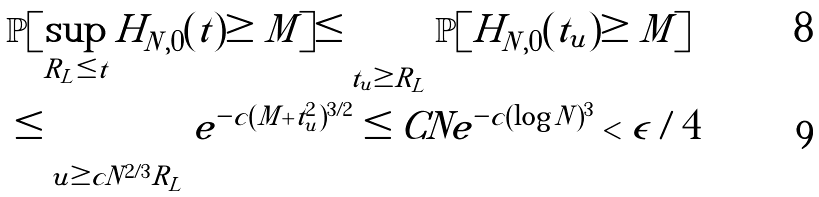Convert formula to latex. <formula><loc_0><loc_0><loc_500><loc_500>& \mathbb { P } [ \sup _ { R _ { L } \leq t } H _ { N , 0 } ( t ) \geq M ] \leq \sum _ { t _ { u } \geq R _ { L } } \mathbb { P } [ H _ { N , 0 } ( t _ { u } ) \geq M ] \\ & \leq \sum _ { u \geq c N ^ { 2 / 3 } R _ { L } } e ^ { - c ( M + t _ { u } ^ { 2 } ) ^ { 3 / 2 } } \leq C N e ^ { - c ( \log N ) ^ { 3 } } < \epsilon / 4</formula> 